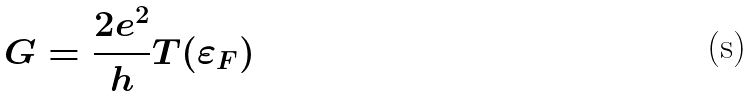Convert formula to latex. <formula><loc_0><loc_0><loc_500><loc_500>G = \frac { 2 e ^ { 2 } } { h } T ( \varepsilon _ { F } )</formula> 